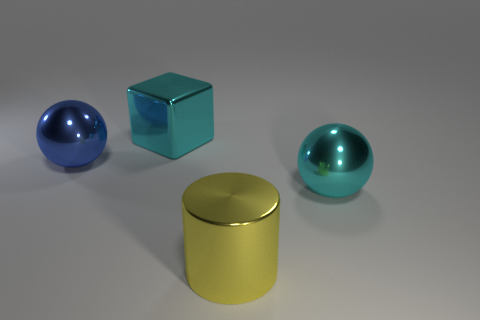Add 3 yellow cylinders. How many objects exist? 7 Subtract all cylinders. How many objects are left? 3 Subtract 1 blocks. How many blocks are left? 0 Add 3 tiny purple rubber cylinders. How many tiny purple rubber cylinders exist? 3 Subtract all blue spheres. How many spheres are left? 1 Subtract 1 cyan cubes. How many objects are left? 3 Subtract all purple cylinders. Subtract all cyan balls. How many cylinders are left? 1 Subtract all gray cylinders. How many yellow blocks are left? 0 Subtract all shiny spheres. Subtract all large metal blocks. How many objects are left? 1 Add 1 blue metallic objects. How many blue metallic objects are left? 2 